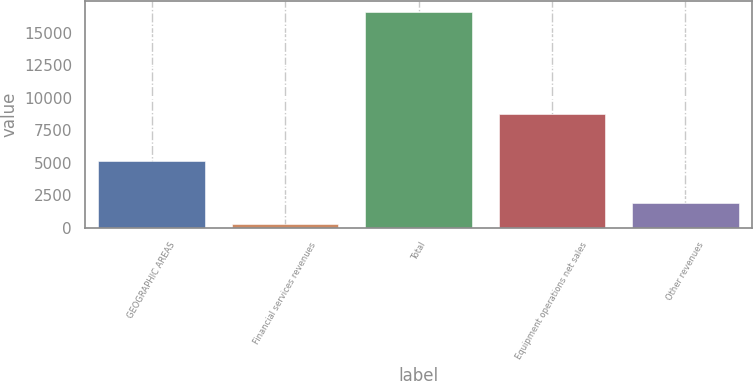Convert chart to OTSL. <chart><loc_0><loc_0><loc_500><loc_500><bar_chart><fcel>GEOGRAPHIC AREAS<fcel>Financial services revenues<fcel>Total<fcel>Equipment operations net sales<fcel>Other revenues<nl><fcel>5163.2<fcel>257<fcel>16611<fcel>8779<fcel>1892.4<nl></chart> 